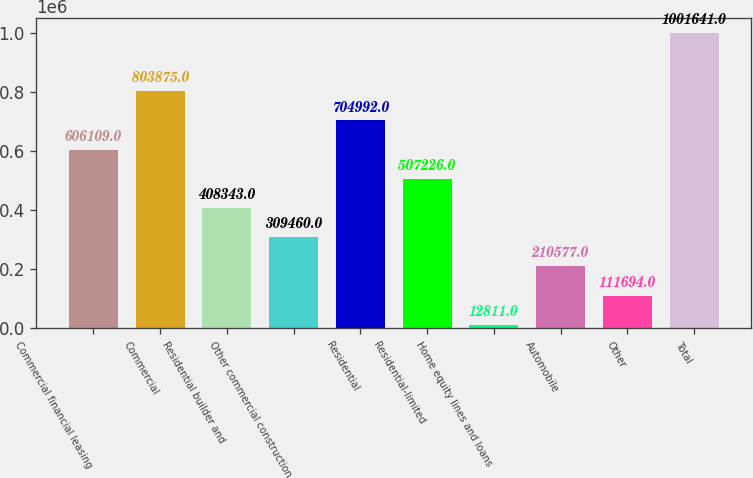Convert chart to OTSL. <chart><loc_0><loc_0><loc_500><loc_500><bar_chart><fcel>Commercial financial leasing<fcel>Commercial<fcel>Residential builder and<fcel>Other commercial construction<fcel>Residential<fcel>Residential-limited<fcel>Home equity lines and loans<fcel>Automobile<fcel>Other<fcel>Total<nl><fcel>606109<fcel>803875<fcel>408343<fcel>309460<fcel>704992<fcel>507226<fcel>12811<fcel>210577<fcel>111694<fcel>1.00164e+06<nl></chart> 